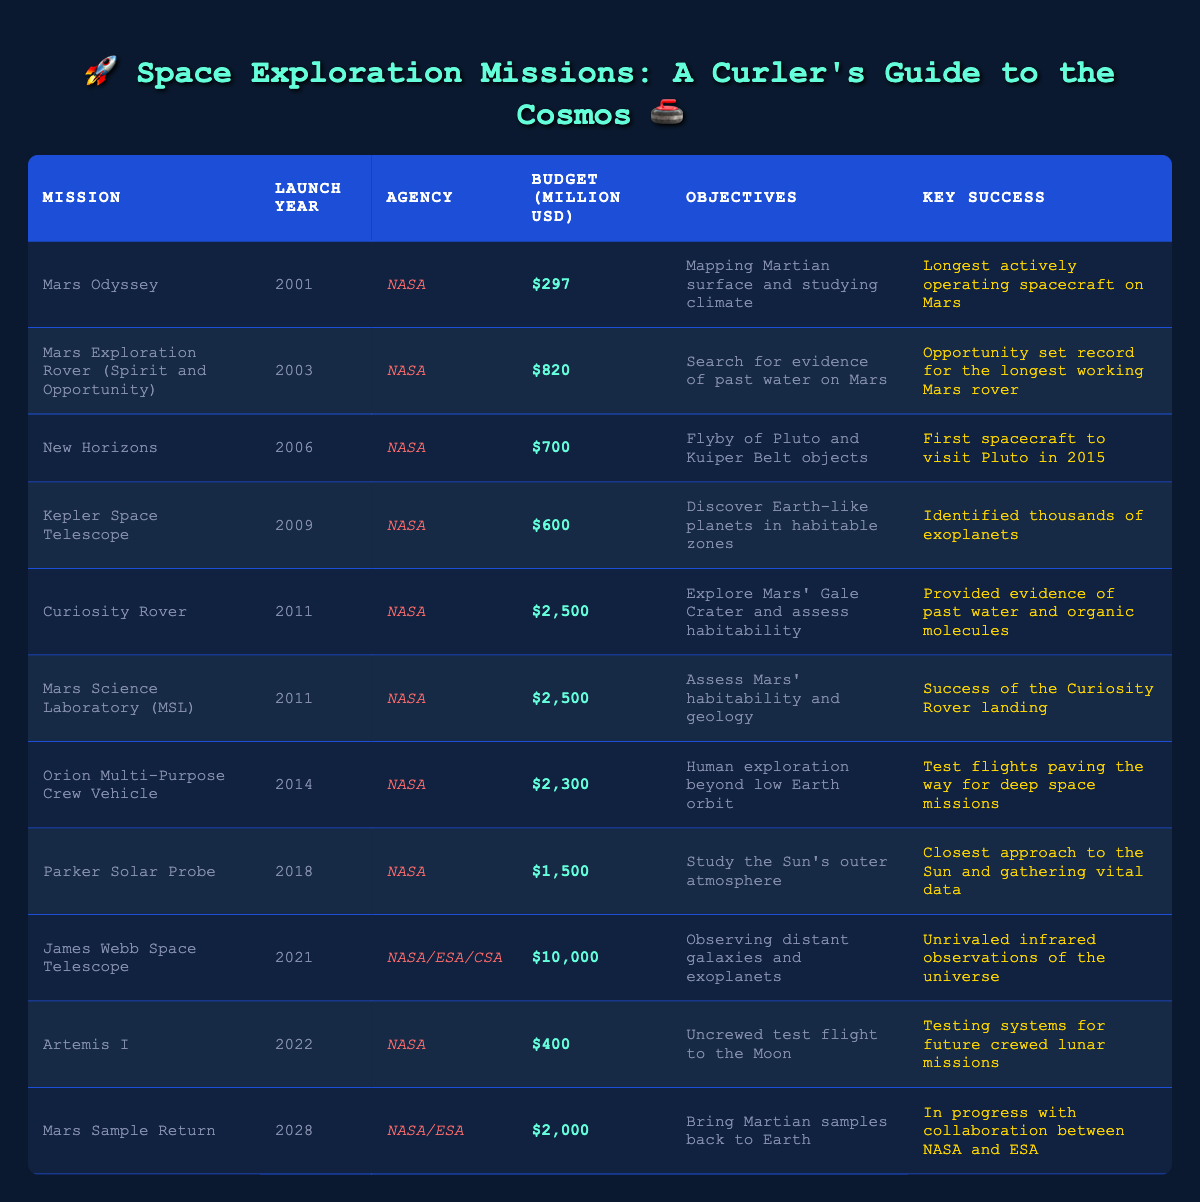What is the total budget for the Mars missions listed in the table? The Mars missions include Mars Odyssey ($297 million), Mars Exploration Rover (Spirit and Opportunity) ($820 million), Curiosity Rover ($2,500 million), Mars Science Laboratory (MSL) ($2,500 million), and Mars Sample Return ($2,000 million). Adding these amounts gives $297 + $820 + $2500 + $2500 + $2000 = $8207 million.
Answer: $8207 million Which mission had the highest budget? From the table, the mission with the highest budget is the James Webb Space Telescope with a budget of $10,000 million.
Answer: James Webb Space Telescope Did the Orion Multi-Purpose Crew Vehicle have a higher budget than the Parker Solar Probe? The Orion Multi-Purpose Crew Vehicle had a budget of $2,300 million, while the Parker Solar Probe had a budget of $1,500 million. Since $2,300 million is greater than $1,500 million, the statement is true.
Answer: Yes How much did the Curiosity Rover and Mars Science Laboratory (MSL) missions cost together? The Curiosity Rover had a budget of $2,500 million and the Mars Science Laboratory (MSL) also had a budget of $2,500 million. Adding both budgets gives $2,500 + $2,500 = $5,000 million.
Answer: $5,000 million What is the average budget of missions launched between 2010 and 2022? The missions launched between 2010 and 2022 are Curiosity Rover ($2,500 million), Mars Science Laboratory (MSL) ($2,500 million), Orion Multi-Purpose Crew Vehicle ($2,300 million), Parker Solar Probe ($1,500 million), James Webb Space Telescope ($10,000 million), Artemis I ($400 million). The total budget is $2,500 + $2,500 + $2,300 + $1,500 + $10,000 + $400 = $19,200 million. There are 6 missions, so the average is $19,200 / 6 = $3,200 million.
Answer: $3,200 million Which agency was responsible for the most missions listed in the table? By reviewing the table, NASA is listed as the agency for 8 out of the 10 missions, while NASA/ESA/CSA is counted once for the James Webb Space Telescope and NASA/ESA once for Mars Sample Return. Therefore, NASA is responsible for the majority.
Answer: NASA Is it true that all missions launched after 2010 have budgets over $500 million? The missions after 2010 (Curiosity Rover, Mars Science Laboratory, Orion Multi-Purpose Crew Vehicle, Parker Solar Probe, James Webb Space Telescope, and Artemis I) have budgets of $2,500 million, $2,500 million, $2,300 million, $1,500 million, $10,000 million, and $400 million. Artemis I has a budget of $400 million which is below $500 million, making the statement false.
Answer: No What was the budget difference between the James Webb Space Telescope and the Curiosity Rover? The budget for the James Webb Space Telescope is $10,000 million and for the Curiosity Rover it is $2,500 million. The difference is $10,000 - $2,500 = $7,500 million.
Answer: $7,500 million Which mission's key success is related to evidence of past water and organic molecules? The mission associated with providing evidence of past water and organic molecules is the Curiosity Rover.
Answer: Curiosity Rover What percentage of the total budget for NASA missions is spent on the James Webb Space Telescope? Summing up the budgets of NASA missions (all except James Webb Space Telescope): $297 + $820 + $700 + $600 + $2,500 + $2,500 + $2,300 + $1,500 = $11,217 million. Adding the James Webb Space Telescope's budget gives $11,217 + $10,000 = $21,217 million. The percentage spent on James Webb is ($10,000 / $21,217) * 100 = approximately 47.13%.
Answer: 47.13% What mission aims to bring Martian samples back to Earth? The mission with the objective of bringing Martian samples back to Earth is the Mars Sample Return mission.
Answer: Mars Sample Return 